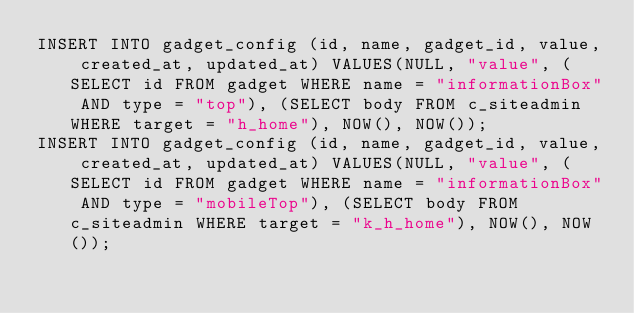<code> <loc_0><loc_0><loc_500><loc_500><_SQL_>INSERT INTO gadget_config (id, name, gadget_id, value, created_at, updated_at) VALUES(NULL, "value", (SELECT id FROM gadget WHERE name = "informationBox" AND type = "top"), (SELECT body FROM c_siteadmin WHERE target = "h_home"), NOW(), NOW());
INSERT INTO gadget_config (id, name, gadget_id, value, created_at, updated_at) VALUES(NULL, "value", (SELECT id FROM gadget WHERE name = "informationBox" AND type = "mobileTop"), (SELECT body FROM c_siteadmin WHERE target = "k_h_home"), NOW(), NOW());

</code> 